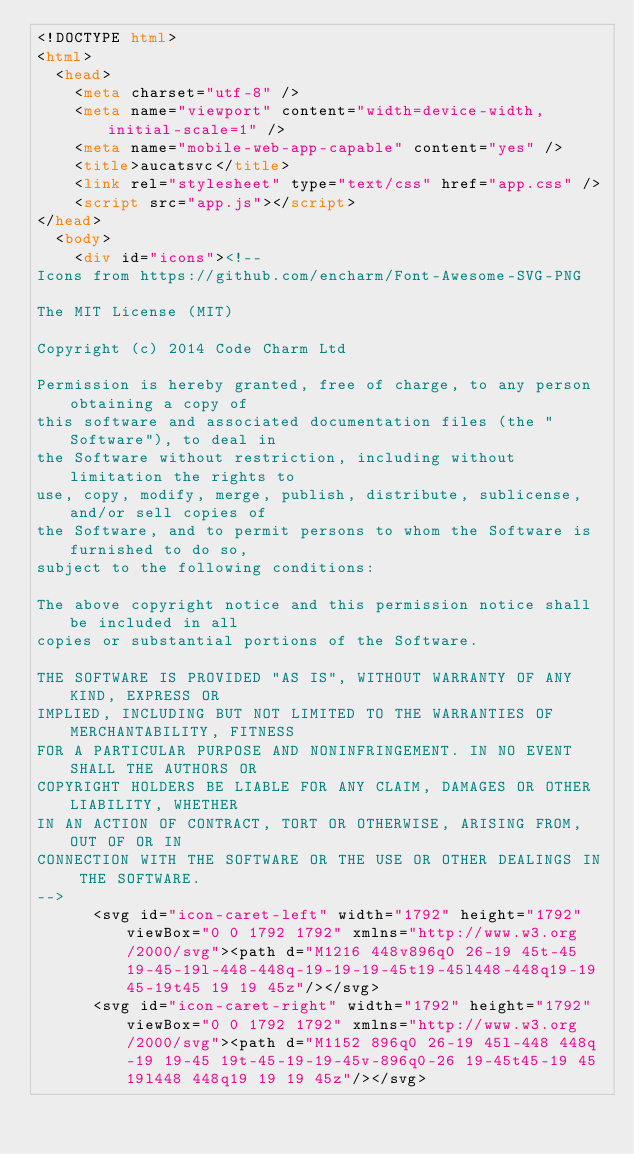Convert code to text. <code><loc_0><loc_0><loc_500><loc_500><_HTML_><!DOCTYPE html>
<html>
  <head>
    <meta charset="utf-8" />
    <meta name="viewport" content="width=device-width, initial-scale=1" />
    <meta name="mobile-web-app-capable" content="yes" />
    <title>aucatsvc</title>
    <link rel="stylesheet" type="text/css" href="app.css" />
    <script src="app.js"></script>
</head>
  <body>
    <div id="icons"><!--
Icons from https://github.com/encharm/Font-Awesome-SVG-PNG

The MIT License (MIT)

Copyright (c) 2014 Code Charm Ltd

Permission is hereby granted, free of charge, to any person obtaining a copy of
this software and associated documentation files (the "Software"), to deal in
the Software without restriction, including without limitation the rights to
use, copy, modify, merge, publish, distribute, sublicense, and/or sell copies of
the Software, and to permit persons to whom the Software is furnished to do so,
subject to the following conditions:

The above copyright notice and this permission notice shall be included in all
copies or substantial portions of the Software.

THE SOFTWARE IS PROVIDED "AS IS", WITHOUT WARRANTY OF ANY KIND, EXPRESS OR
IMPLIED, INCLUDING BUT NOT LIMITED TO THE WARRANTIES OF MERCHANTABILITY, FITNESS
FOR A PARTICULAR PURPOSE AND NONINFRINGEMENT. IN NO EVENT SHALL THE AUTHORS OR
COPYRIGHT HOLDERS BE LIABLE FOR ANY CLAIM, DAMAGES OR OTHER LIABILITY, WHETHER
IN AN ACTION OF CONTRACT, TORT OR OTHERWISE, ARISING FROM, OUT OF OR IN
CONNECTION WITH THE SOFTWARE OR THE USE OR OTHER DEALINGS IN THE SOFTWARE.
-->
      <svg id="icon-caret-left" width="1792" height="1792" viewBox="0 0 1792 1792" xmlns="http://www.w3.org/2000/svg"><path d="M1216 448v896q0 26-19 45t-45 19-45-19l-448-448q-19-19-19-45t19-45l448-448q19-19 45-19t45 19 19 45z"/></svg>
      <svg id="icon-caret-right" width="1792" height="1792" viewBox="0 0 1792 1792" xmlns="http://www.w3.org/2000/svg"><path d="M1152 896q0 26-19 45l-448 448q-19 19-45 19t-45-19-19-45v-896q0-26 19-45t45-19 45 19l448 448q19 19 19 45z"/></svg></code> 